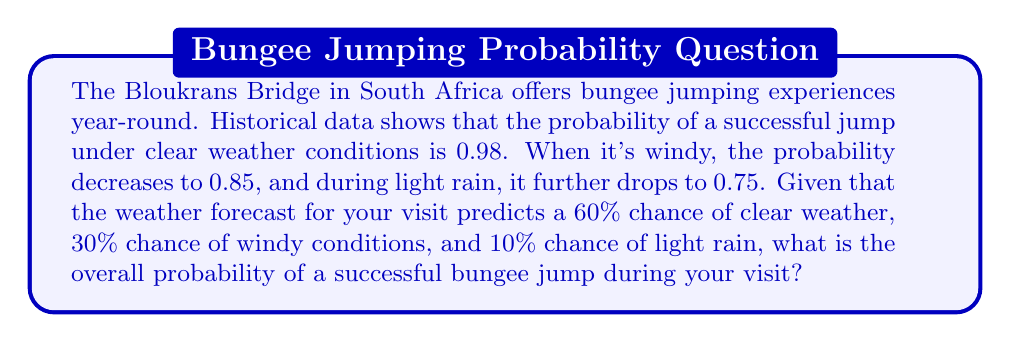Give your solution to this math problem. Let's approach this step-by-step using the law of total probability:

1) Define events:
   S: Successful jump
   C: Clear weather
   W: Windy conditions
   R: Light rain

2) Given probabilities:
   P(S|C) = 0.98 (probability of success given clear weather)
   P(S|W) = 0.85 (probability of success given windy conditions)
   P(S|R) = 0.75 (probability of success given light rain)
   P(C) = 0.60 (probability of clear weather)
   P(W) = 0.30 (probability of windy conditions)
   P(R) = 0.10 (probability of light rain)

3) Using the law of total probability:
   $$P(S) = P(S|C)P(C) + P(S|W)P(W) + P(S|R)P(R)$$

4) Substituting the values:
   $$P(S) = (0.98)(0.60) + (0.85)(0.30) + (0.75)(0.10)$$

5) Calculating:
   $$P(S) = 0.588 + 0.255 + 0.075 = 0.918$$

Therefore, the overall probability of a successful bungee jump during your visit is 0.918 or 91.8%.
Answer: 0.918 